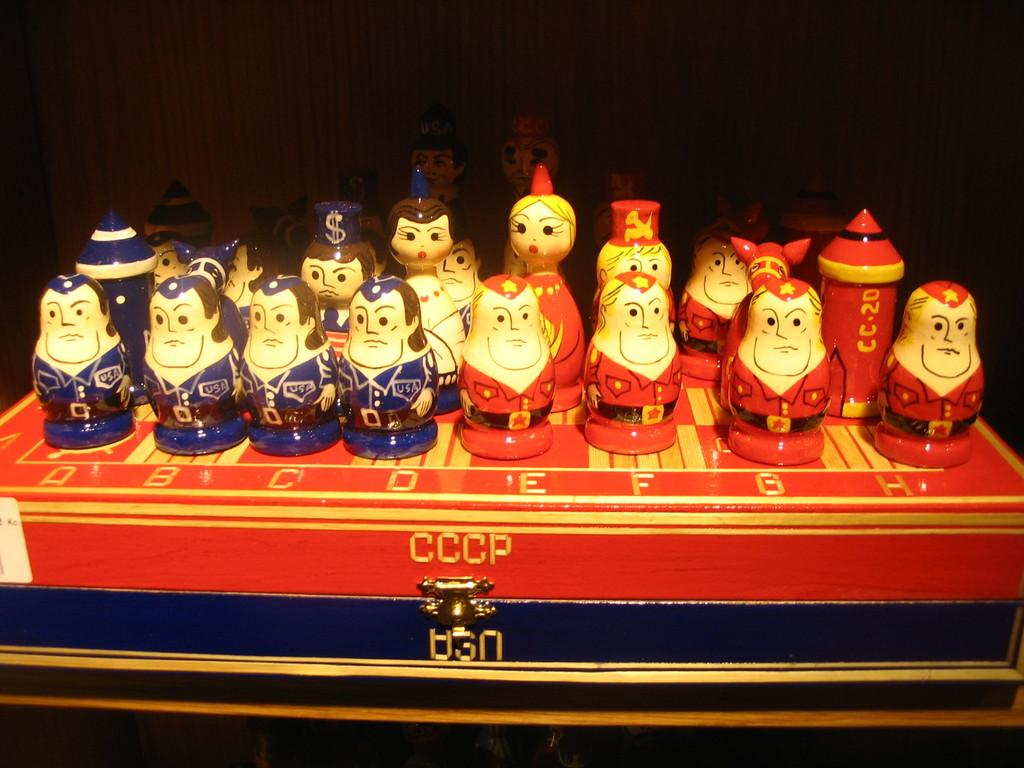What objects are present in the image? There are figurines in the image. What can be observed about the background of the image? The background of the image is dark. Where is the box located in the image? There is a box at the bottom of the image. How many faces can be seen on the floor in the image? There are no faces visible on the floor in the image. 